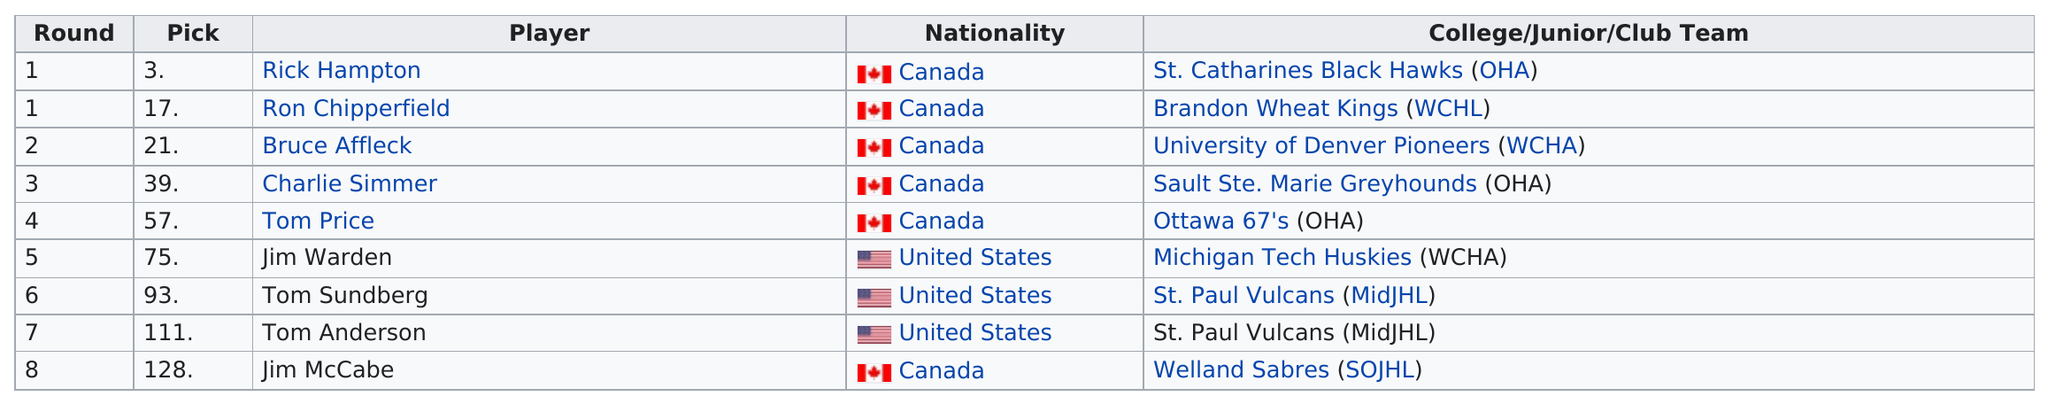Outline some significant characteristics in this image. Jim McCabe was chosen in the last round. In the 1974-75 Golden Seals hockey season, two draft picks were taken in the first round. The majority of the amateur draft picks from Canada are comprised of amateur draft picks from the United States, with a significant number of players coming from Canada. There are 7 rounds on the list after round 1. In the 1974-75 Golden Seals hockey season, six of the team's draft picks were Canadian. 